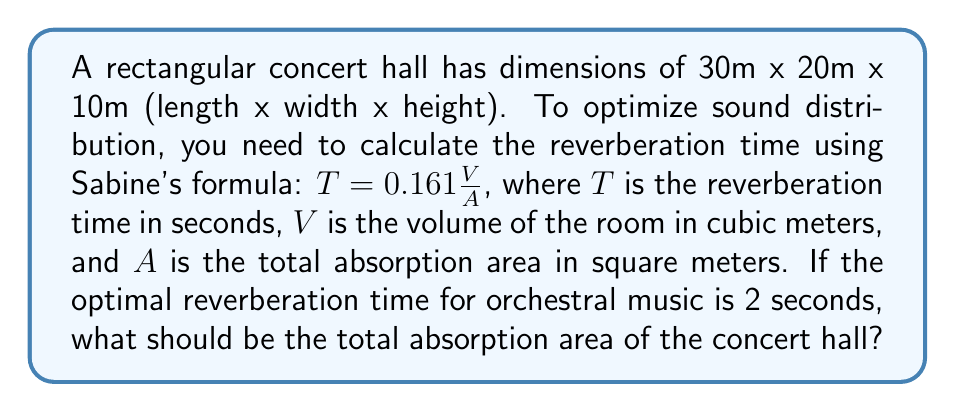Provide a solution to this math problem. 1. Calculate the volume of the concert hall:
   $V = 30\text{m} \times 20\text{m} \times 10\text{m} = 6000\text{m}^3$

2. Use Sabine's formula and substitute the known values:
   $2\text{s} = 0.161 \frac{6000\text{m}^3}{A}$

3. Solve for $A$:
   $A = 0.161 \frac{6000\text{m}^3}{2\text{s}}$

4. Calculate the result:
   $A = 483\text{m}^2$

Therefore, to achieve the optimal reverberation time of 2 seconds for orchestral music in this concert hall, the total absorption area should be 483 square meters.
Answer: $483\text{m}^2$ 